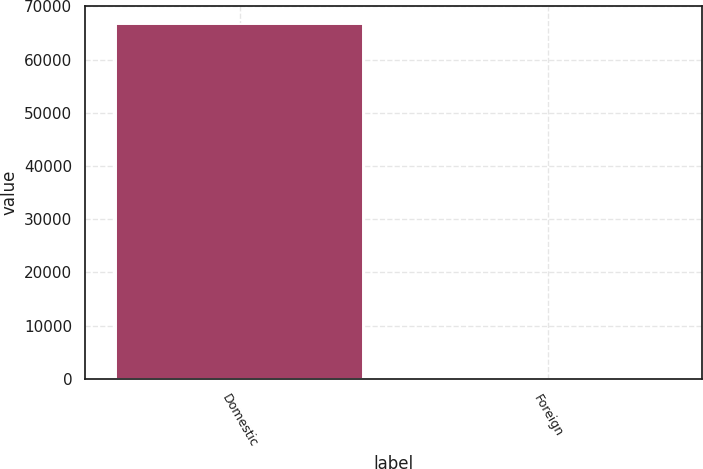Convert chart to OTSL. <chart><loc_0><loc_0><loc_500><loc_500><bar_chart><fcel>Domestic<fcel>Foreign<nl><fcel>66756<fcel>7<nl></chart> 